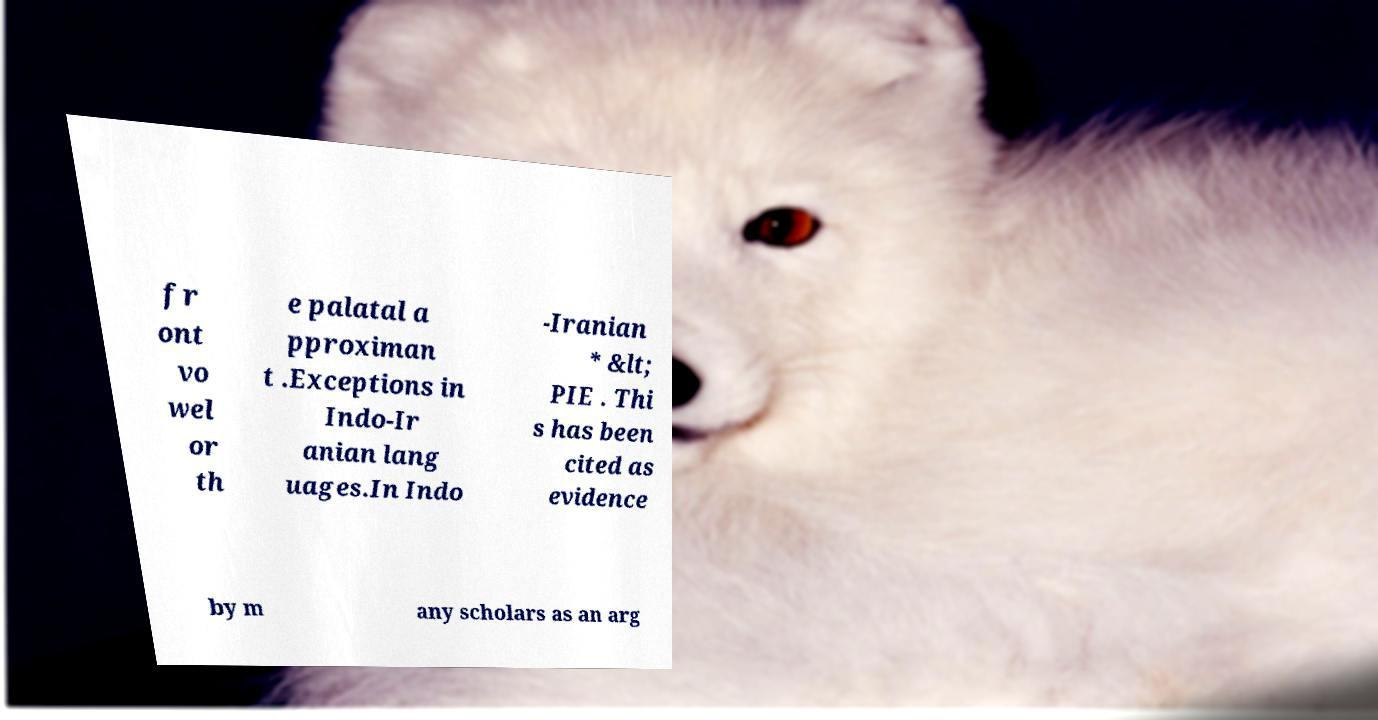Could you assist in decoding the text presented in this image and type it out clearly? fr ont vo wel or th e palatal a pproximan t .Exceptions in Indo-Ir anian lang uages.In Indo -Iranian * &lt; PIE . Thi s has been cited as evidence by m any scholars as an arg 